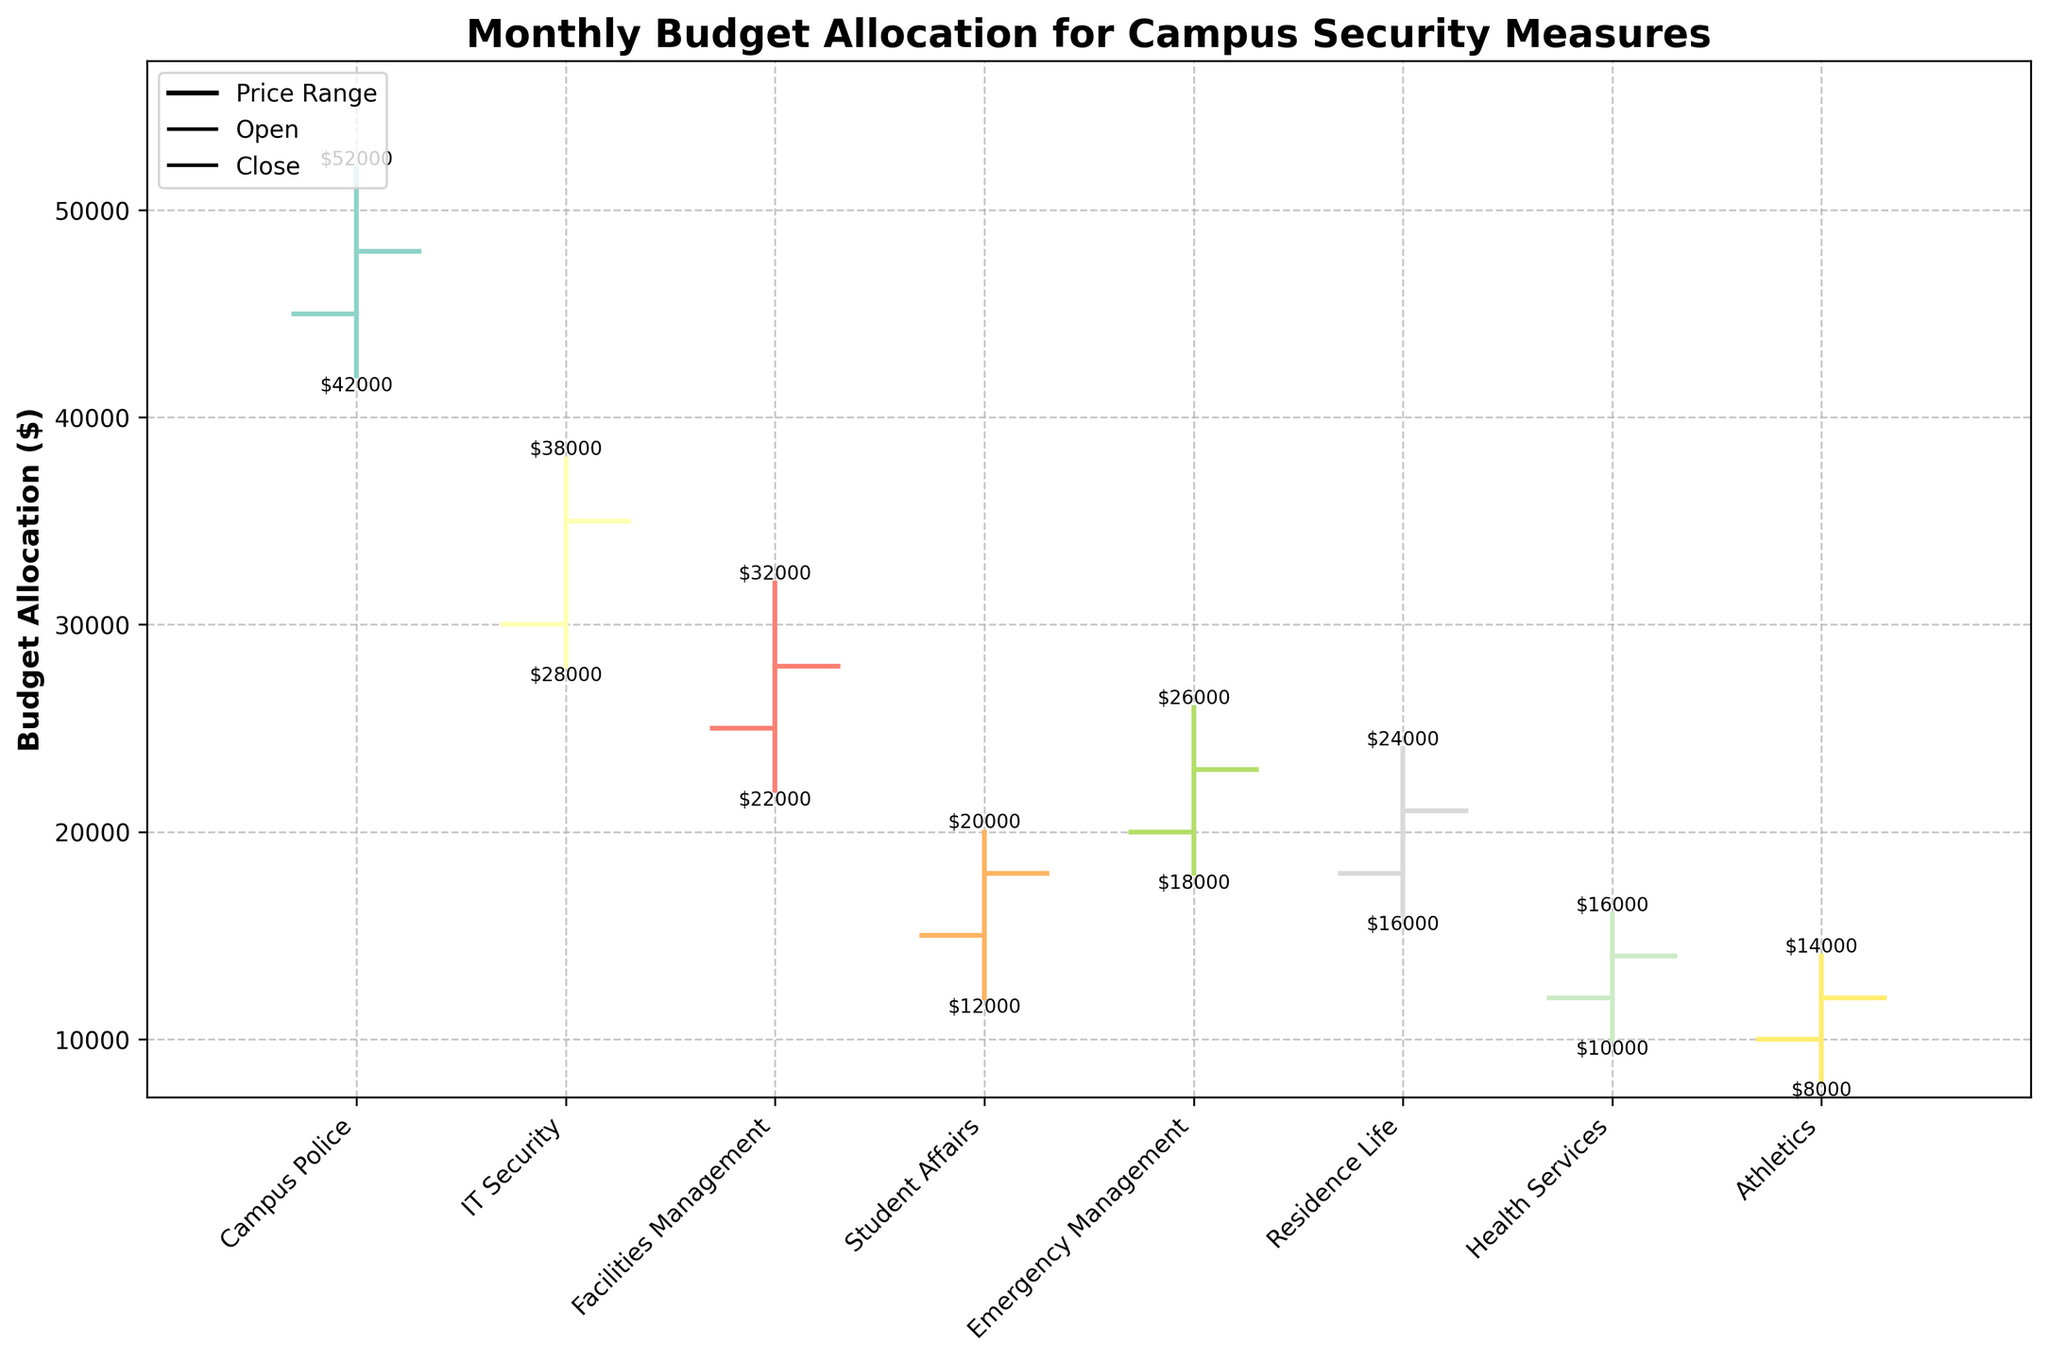What is the highest budget allocation for Campus Police? Look at the highest budgeted amount for Campus Police on the y-axis.
Answer: $52000 Which department has the lowest opening budget? Compare the opening budgets of all departments and find the lowest one.
Answer: Athletics How much did the budget for IT Security increase from the open to the close? Subtract the opening budget from the closing budget for IT Security: $35000 - $30000.
Answer: $5000 Which department shows the most fluctuation in budget allocation? Compare the range (difference between high and low) of all departments. The one with the largest range has the most fluctuation.
Answer: Campus Police What is the total high budget for Facilities Management and Student Affairs? Add the high budget values of Facilities Management ($32000) and Student Affairs ($20000).
Answer: $52000 Which two departments have a closing budget that is greater than their opening budget? Compare the closing and opening budgets of each department and identify those where the closing budget is higher.
Answer: Student Affairs, Residence Life What is the average closing budget across all departments? Sum all the closing budgets and divide by the number of departments.
Answer: $25250 Which department had the highest opening budget, and what was the value? Look at the opening budgets and identify the highest one.
Answer: Campus Police, $45000 Between Emergency Management and Health Services, which department had a higher low budget? Compare the low budgets of Emergency Management ($18000) and Health Services ($10000).
Answer: Emergency Management What is the difference between the high and low budget allocations for Residence Life? Subtract the low budget from the high budget for Residence Life: $24000 - $16000.
Answer: $8000 